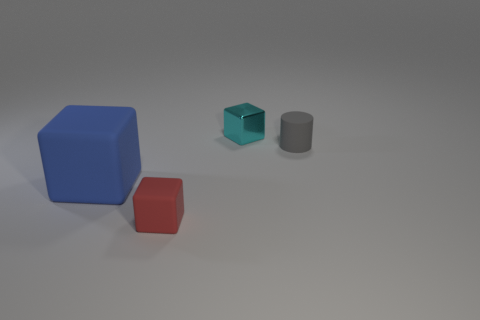Do the cyan thing and the rubber object that is behind the blue object have the same size?
Provide a succinct answer. Yes. There is a rubber thing on the right side of the small metal block; what shape is it?
Give a very brief answer. Cylinder. Are there any other things that have the same shape as the shiny object?
Your answer should be compact. Yes. Is there a big metallic ball?
Ensure brevity in your answer.  No. There is a thing that is on the right side of the metal thing; does it have the same size as the matte cube right of the large object?
Make the answer very short. Yes. What is the cube that is on the right side of the blue block and on the left side of the small cyan metal block made of?
Offer a very short reply. Rubber. What number of things are on the right side of the large cube?
Your answer should be very brief. 3. Are there any other things that are the same size as the red matte object?
Offer a very short reply. Yes. There is a cube that is the same material as the blue object; what color is it?
Your answer should be compact. Red. Do the tiny gray matte thing and the red thing have the same shape?
Your answer should be compact. No. 